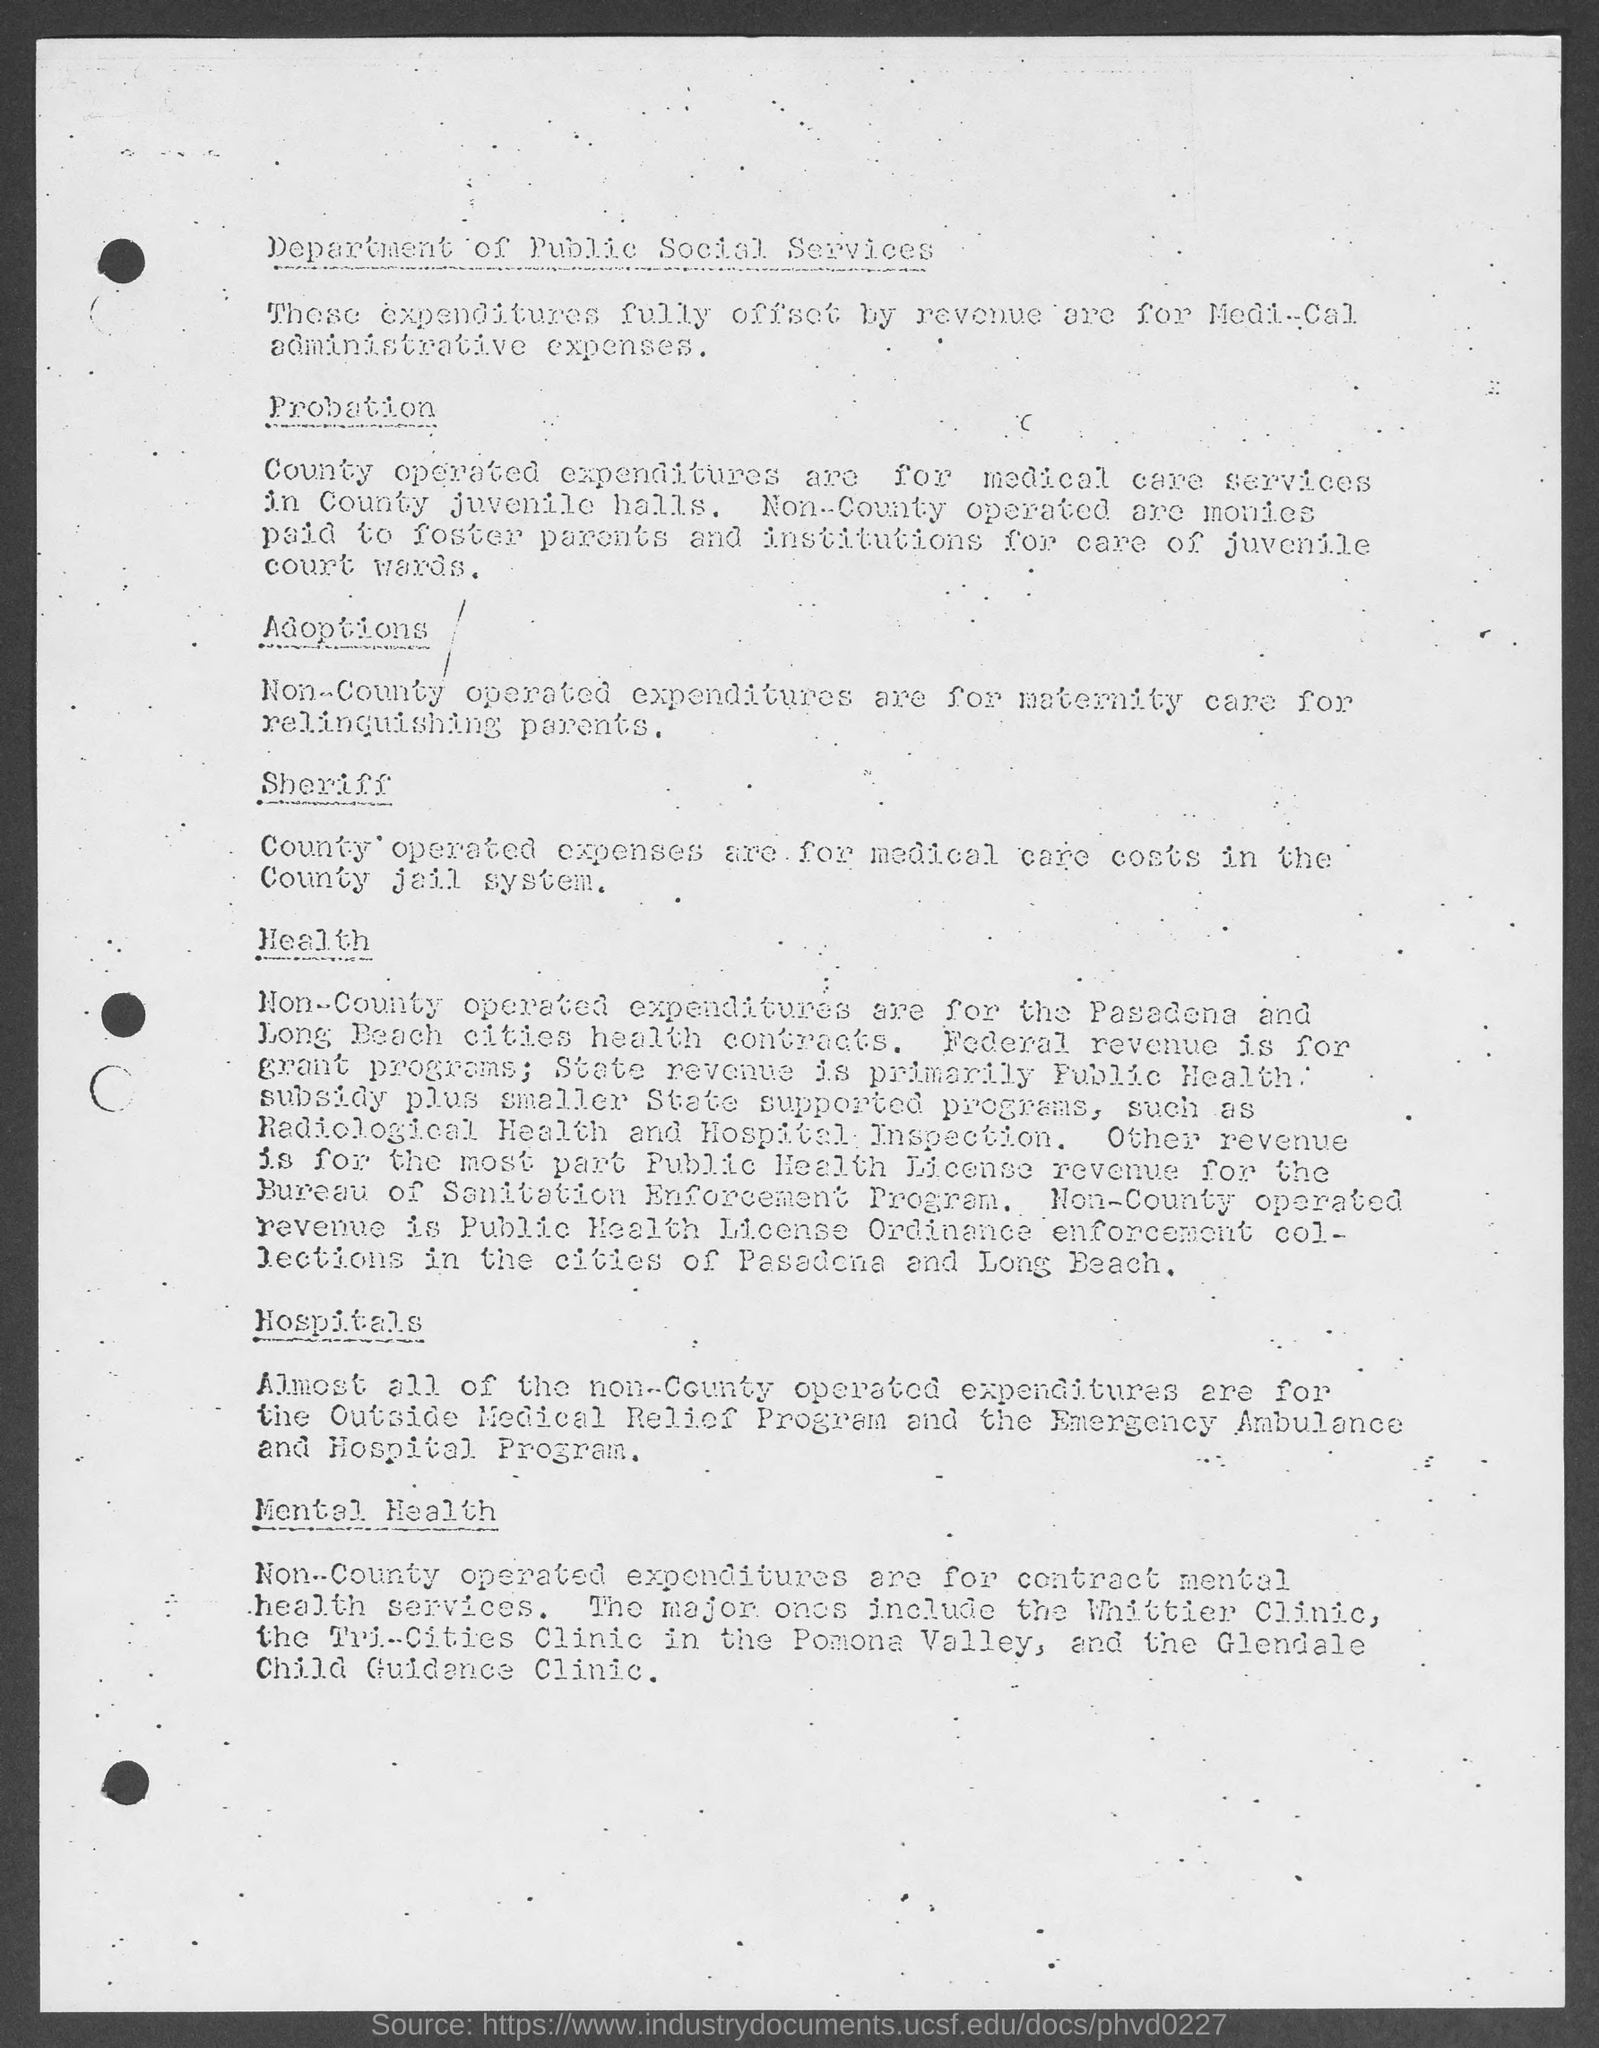List a handful of essential elements in this visual. The County operates expenditures are primarily used for providing medical care services to juveniles in its juvenile halls. 